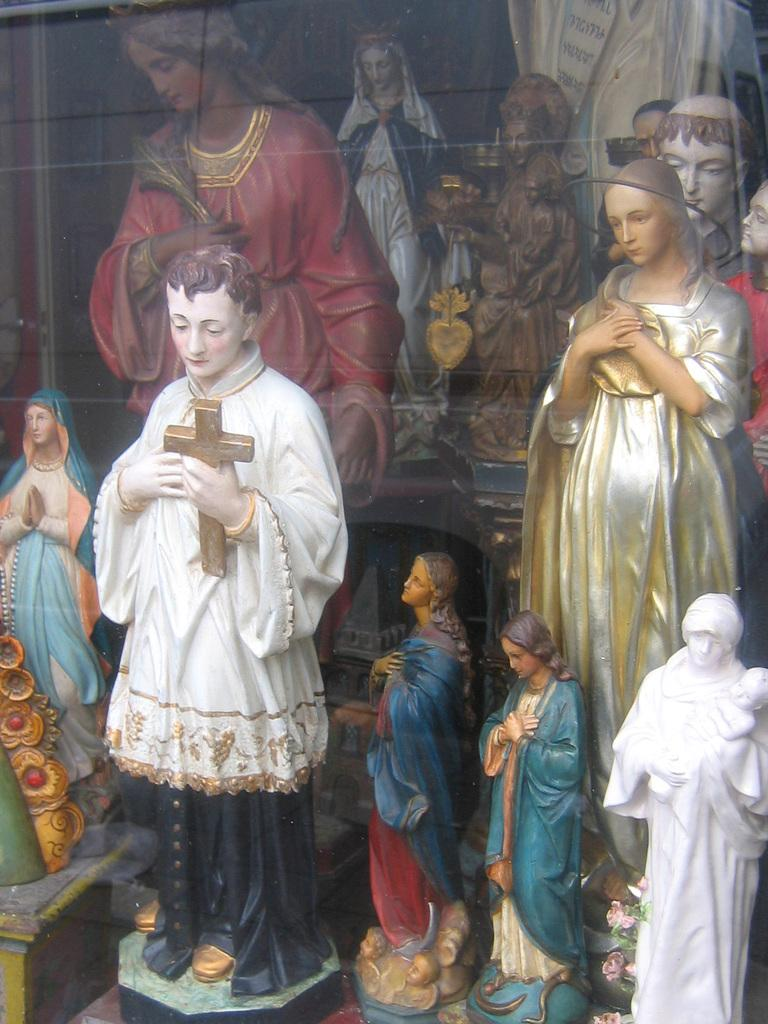What type of objects can be seen in the image? There are statues in the image. What type of balls can be seen in the image? There are no balls present in the image; it only features statues. What kind of jewel is being worn by the statues in the image? There is no mention of any jewelry or jewels in the image, as it only contains statues. 